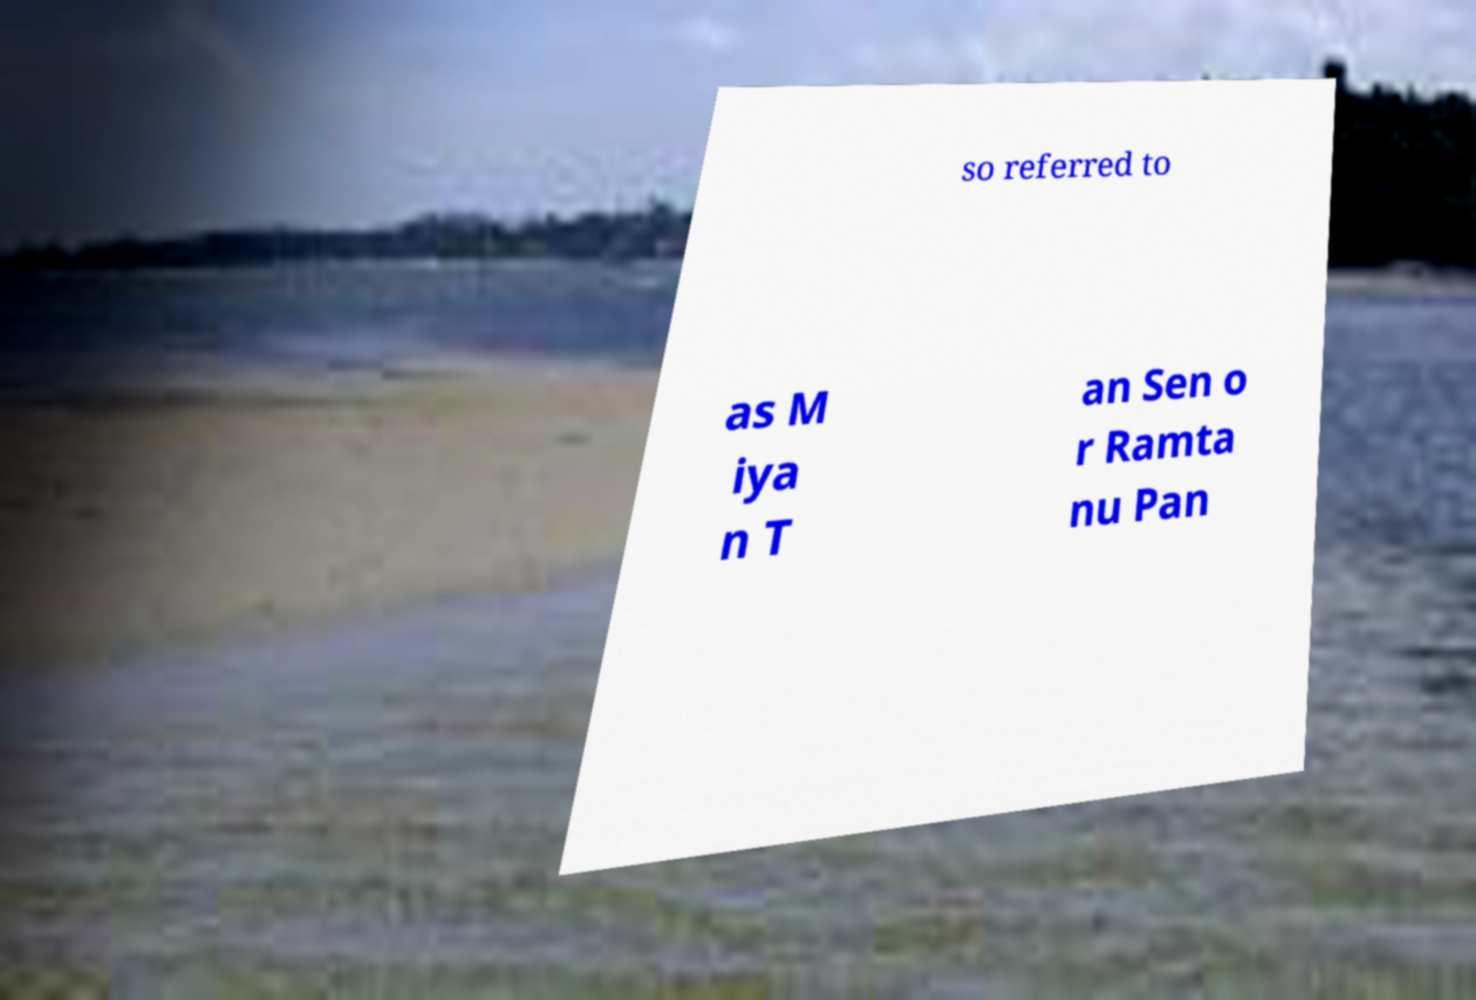For documentation purposes, I need the text within this image transcribed. Could you provide that? so referred to as M iya n T an Sen o r Ramta nu Pan 